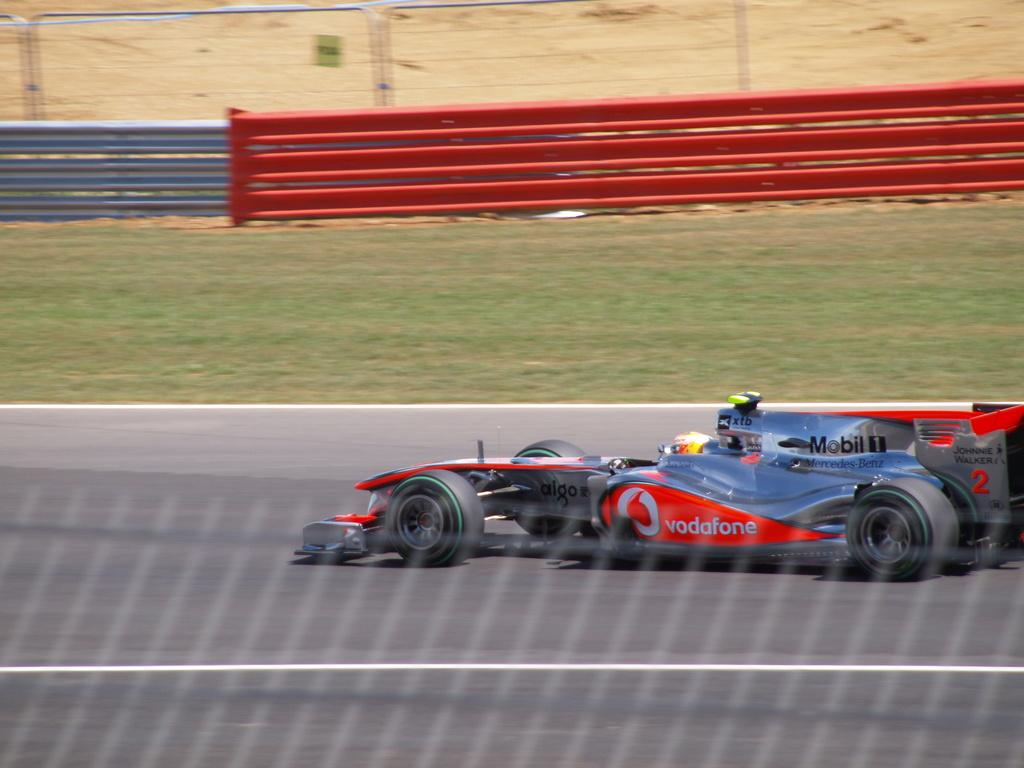What type of vehicle is on the road in the image? There is a sports car on the road in the image. What is the surface of the ground in the image? The ground in the image has grass. What is the purpose of the fence in the image? The purpose of the fence in the image is not specified, but it could be for enclosing an area or providing a barrier. What type of church can be seen in the image? There is no church present in the image; it features a sports car on the road, grassy ground, and a fence. 